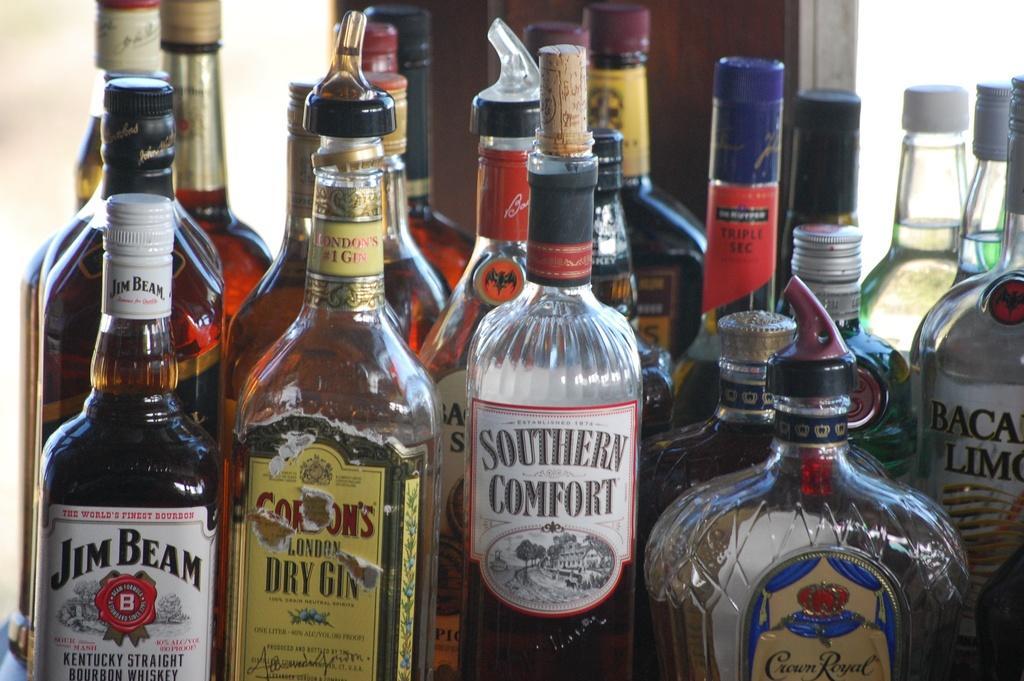Describe this image in one or two sentences. In this image there are bottle. In the left on bottle it is written ¨JEAM BEAM¨. On the middle it is written ¨SOUTHERN COMFORT¨. 